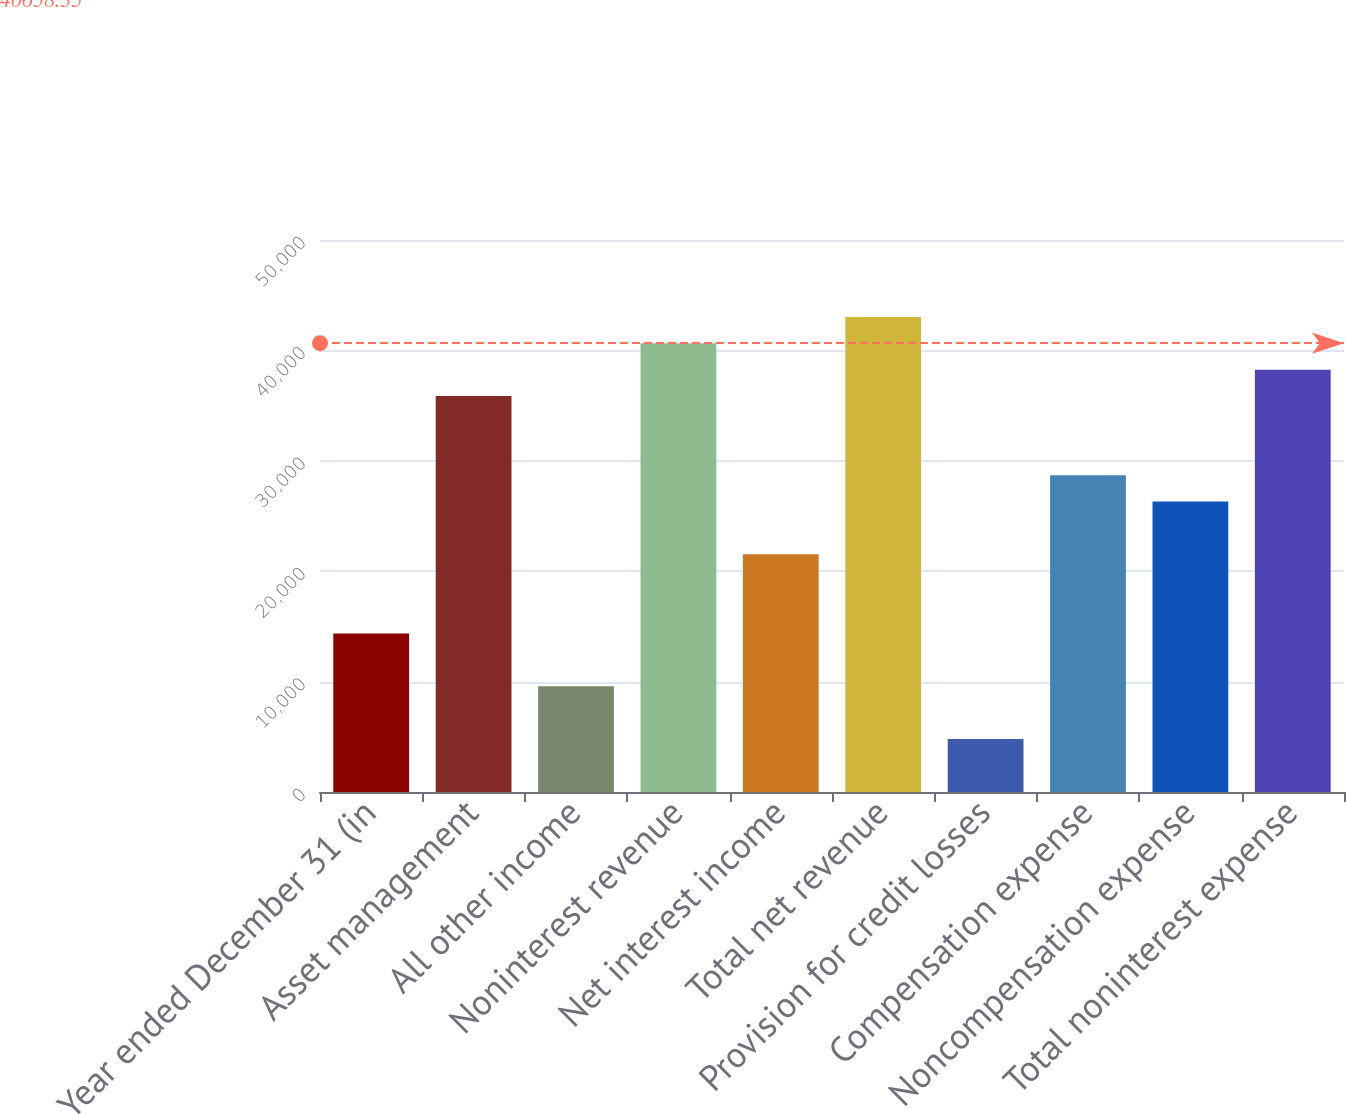Convert chart. <chart><loc_0><loc_0><loc_500><loc_500><bar_chart><fcel>Year ended December 31 (in<fcel>Asset management<fcel>All other income<fcel>Noninterest revenue<fcel>Net interest income<fcel>Total net revenue<fcel>Provision for credit losses<fcel>Compensation expense<fcel>Noncompensation expense<fcel>Total noninterest expense<nl><fcel>14362.4<fcel>35867<fcel>9583.6<fcel>40645.8<fcel>21530.6<fcel>43035.2<fcel>4804.8<fcel>28698.8<fcel>26309.4<fcel>38256.4<nl></chart> 